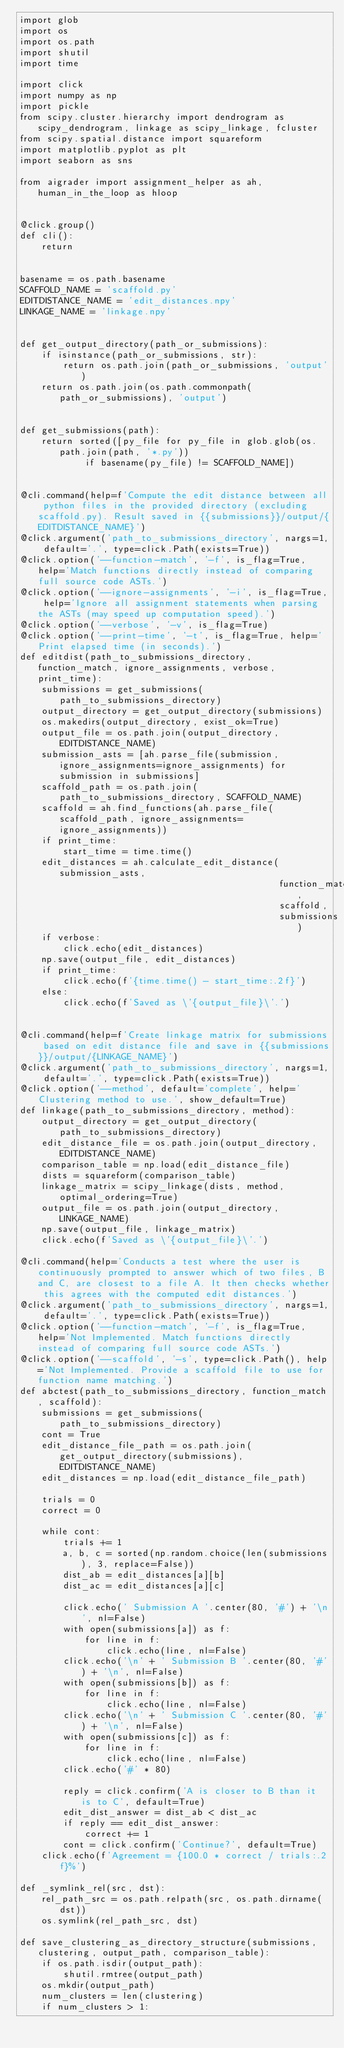Convert code to text. <code><loc_0><loc_0><loc_500><loc_500><_Python_>import glob
import os
import os.path
import shutil
import time

import click
import numpy as np
import pickle
from scipy.cluster.hierarchy import dendrogram as scipy_dendrogram, linkage as scipy_linkage, fcluster
from scipy.spatial.distance import squareform
import matplotlib.pyplot as plt
import seaborn as sns

from aigrader import assignment_helper as ah, human_in_the_loop as hloop


@click.group()
def cli():
    return


basename = os.path.basename
SCAFFOLD_NAME = 'scaffold.py'
EDITDISTANCE_NAME = 'edit_distances.npy'
LINKAGE_NAME = 'linkage.npy'


def get_output_directory(path_or_submissions):
    if isinstance(path_or_submissions, str):
        return os.path.join(path_or_submissions, 'output')
    return os.path.join(os.path.commonpath(path_or_submissions), 'output')


def get_submissions(path):
    return sorted([py_file for py_file in glob.glob(os.path.join(path, '*.py'))
            if basename(py_file) != SCAFFOLD_NAME])


@cli.command(help=f'Compute the edit distance between all python files in the provided directory (excluding scaffold.py). Result saved in {{submissions}}/output/{EDITDISTANCE_NAME}')
@click.argument('path_to_submissions_directory', nargs=1, default='.', type=click.Path(exists=True))
@click.option('--function-match', '-f', is_flag=True, help='Match functions directly instead of comparing full source code ASTs.')
@click.option('--ignore-assignments', '-i', is_flag=True, help='Ignore all assignment statements when parsing the ASTs (may speed up computation speed).')
@click.option('--verbose', '-v', is_flag=True)
@click.option('--print-time', '-t', is_flag=True, help='Print elapsed time (in seconds).')
def editdist(path_to_submissions_directory, function_match, ignore_assignments, verbose, print_time):
    submissions = get_submissions(path_to_submissions_directory)
    output_directory = get_output_directory(submissions)
    os.makedirs(output_directory, exist_ok=True)
    output_file = os.path.join(output_directory, EDITDISTANCE_NAME)
    submission_asts = [ah.parse_file(submission, ignore_assignments=ignore_assignments) for submission in submissions]
    scaffold_path = os.path.join(path_to_submissions_directory, SCAFFOLD_NAME)
    scaffold = ah.find_functions(ah.parse_file(scaffold_path, ignore_assignments=ignore_assignments))
    if print_time:
        start_time = time.time()
    edit_distances = ah.calculate_edit_distance(submission_asts,
                                                function_match,
                                                scaffold,
                                                submissions)
    if verbose:
        click.echo(edit_distances)
    np.save(output_file, edit_distances)
    if print_time:
        click.echo(f'{time.time() - start_time:.2f}')
    else:
        click.echo(f'Saved as \'{output_file}\'.')


@cli.command(help=f'Create linkage matrix for submissions based on edit distance file and save in {{submissions}}/output/{LINKAGE_NAME}')
@click.argument('path_to_submissions_directory', nargs=1, default='.', type=click.Path(exists=True))
@click.option('--method', default='complete', help='Clustering method to use.', show_default=True)
def linkage(path_to_submissions_directory, method):
    output_directory = get_output_directory(path_to_submissions_directory)
    edit_distance_file = os.path.join(output_directory, EDITDISTANCE_NAME)
    comparison_table = np.load(edit_distance_file)
    dists = squareform(comparison_table)
    linkage_matrix = scipy_linkage(dists, method, optimal_ordering=True)
    output_file = os.path.join(output_directory, LINKAGE_NAME)
    np.save(output_file, linkage_matrix)
    click.echo(f'Saved as \'{output_file}\'.')

@cli.command(help='Conducts a test where the user is continuously prompted to answer which of two files, B and C, are closest to a file A. It then checks whether this agrees with the computed edit distances.')
@click.argument('path_to_submissions_directory', nargs=1, default='.', type=click.Path(exists=True))
@click.option('--function-match', '-f', is_flag=True, help='Not Implemented. Match functions directly instead of comparing full source code ASTs.')
@click.option('--scaffold', '-s', type=click.Path(), help='Not Implemented. Provide a scaffold file to use for function name matching.')
def abctest(path_to_submissions_directory, function_match, scaffold):
    submissions = get_submissions(path_to_submissions_directory)
    cont = True
    edit_distance_file_path = os.path.join(get_output_directory(submissions), EDITDISTANCE_NAME)
    edit_distances = np.load(edit_distance_file_path)

    trials = 0
    correct = 0

    while cont:
        trials += 1
        a, b, c = sorted(np.random.choice(len(submissions), 3, replace=False))
        dist_ab = edit_distances[a][b]
        dist_ac = edit_distances[a][c]

        click.echo(' Submission A '.center(80, '#') + '\n', nl=False)
        with open(submissions[a]) as f:
            for line in f:
                click.echo(line, nl=False)
        click.echo('\n' + ' Submission B '.center(80, '#') + '\n', nl=False)
        with open(submissions[b]) as f:
            for line in f:
                click.echo(line, nl=False)
        click.echo('\n' + ' Submission C '.center(80, '#') + '\n', nl=False)
        with open(submissions[c]) as f:
            for line in f:
                click.echo(line, nl=False)
        click.echo('#' * 80)

        reply = click.confirm('A is closer to B than it is to C', default=True)
        edit_dist_answer = dist_ab < dist_ac
        if reply == edit_dist_answer:
            correct += 1
        cont = click.confirm('Continue?', default=True)
    click.echo(f'Agreement = {100.0 * correct / trials:.2f}%')

def _symlink_rel(src, dst):
    rel_path_src = os.path.relpath(src, os.path.dirname(dst))
    os.symlink(rel_path_src, dst)

def save_clustering_as_directory_structure(submissions, clustering, output_path, comparison_table):
    if os.path.isdir(output_path):
        shutil.rmtree(output_path)
    os.mkdir(output_path)
    num_clusters = len(clustering)
    if num_clusters > 1:</code> 